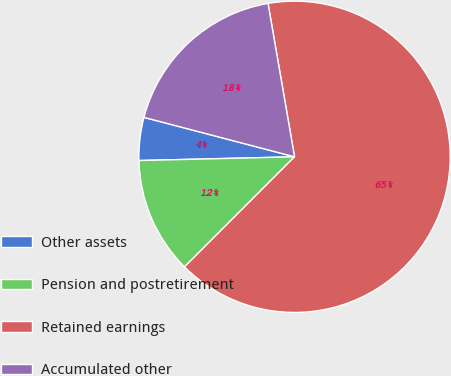<chart> <loc_0><loc_0><loc_500><loc_500><pie_chart><fcel>Other assets<fcel>Pension and postretirement<fcel>Retained earnings<fcel>Accumulated other<nl><fcel>4.46%<fcel>12.12%<fcel>65.23%<fcel>18.2%<nl></chart> 